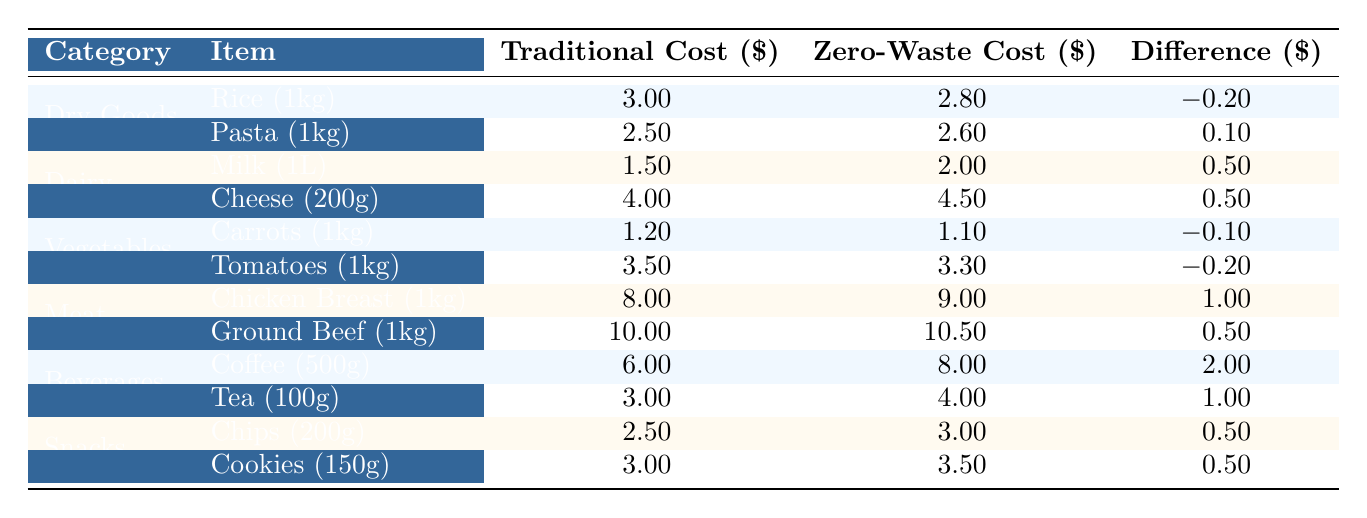What is the total cost of rice and pasta in the traditional grocery shopping category? To find the total cost, we look at the traditional costs for rice and pasta. Rice costs 3.00 and pasta costs 2.50. Adding these together gives 3.00 + 2.50 = 5.50.
Answer: 5.50 Which item has the highest traditional cost in the table? By examining the traditional costs listed for each item, the highest cost is 10.00 for Ground Beef.
Answer: Ground Beef What is the total difference in cost for vegetables when switching from traditional to zero-waste shopping? The difference in cost for carrots is -0.10 and for tomatoes is -0.20. Adding these together gives -0.10 + (-0.20) = -0.30. The cost goes down by a total of 0.30 when switching to zero-waste for vegetables.
Answer: -0.30 Is the zero-waste cost for cheese more expensive than the traditional cost? The zero-waste cost for cheese is 4.50, while the traditional cost is 4.00. Comparing these two values shows that 4.50 is greater than 4.00.
Answer: Yes On average, how much more do you pay for beverages in zero-waste shopping compared to traditional shopping? The costs for beverages are: Coffee (6.00 traditional, 8.00 zero-waste) and Tea (3.00 traditional, 4.00 zero-waste). Summing the traditional costs gives 6.00 + 3.00 = 9.00 and zero-waste costs gives 8.00 + 4.00 = 12.00. The difference is 12.00 - 9.00 = 3.00, so on average you pay more for beverages in zero-waste shopping.
Answer: 3.00 What can we infer about the price trend of dry goods in zero-waste shopping compared to traditional shopping? In dry goods, rice costs 2.80 in zero-waste (lower than traditional 3.00), but pasta costs 2.60 (higher than traditional 2.50). The zero-waste price for dry goods is mixed, suggesting some items are cheaper and some are more expensive.
Answer: Mixed trend 